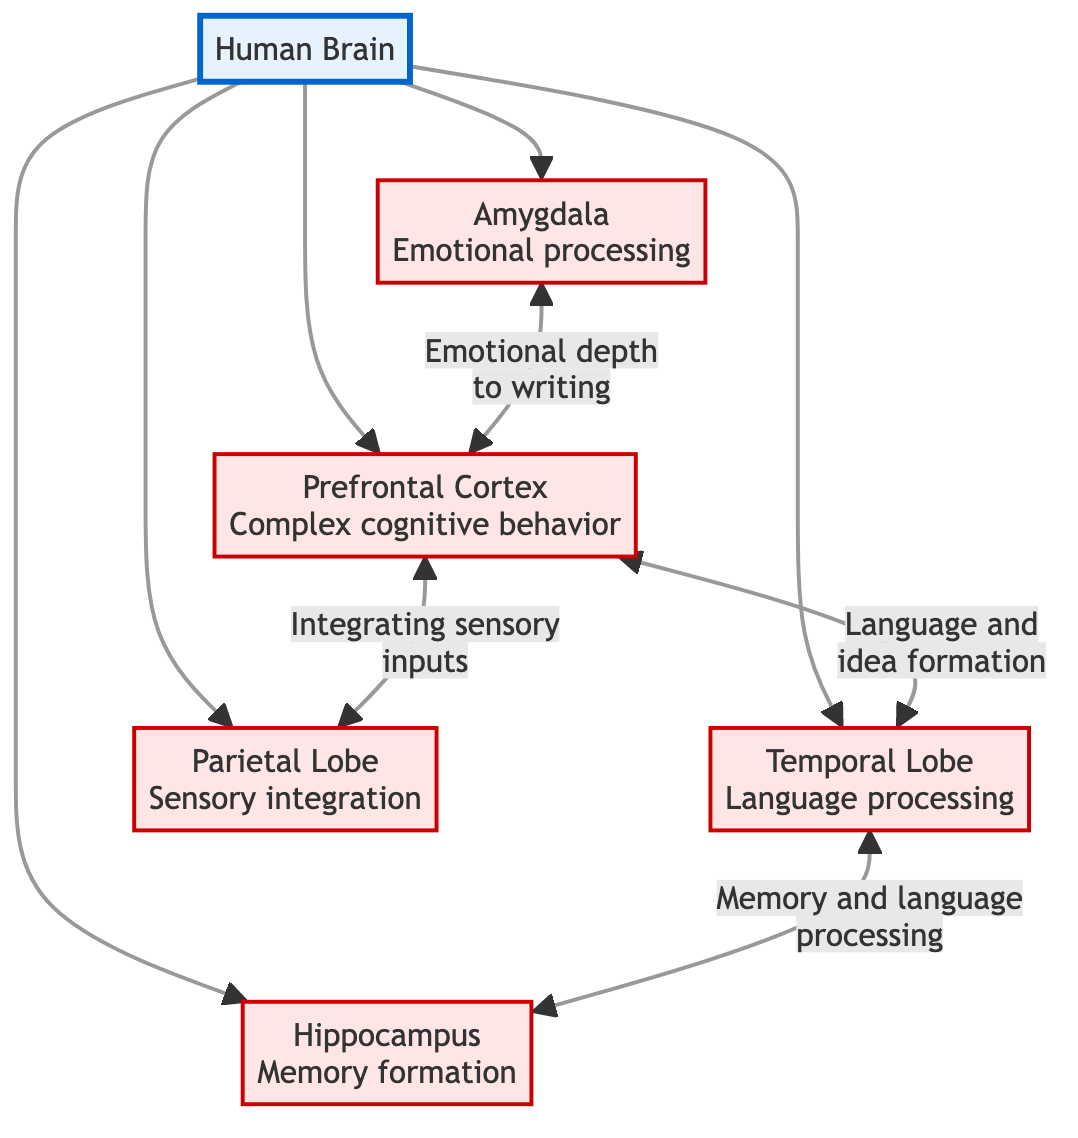What brain region is responsible for complex cognitive behavior? The diagram identifies the Prefrontal Cortex as the region associated with complex cognitive behavior. This can be directly observed as a labeled node connected to the Human Brain node.
Answer: Prefrontal Cortex How many brain regions are involved in the creative writing process according to the diagram? The diagram shows five distinct regions: Prefrontal Cortex, Temporal Lobe, Parietal Lobe, Hippocampus, and Amygdala, all branching from the Human Brain node.
Answer: Five What is the relationship between the Prefrontal Cortex and the Temporal Lobe? The diagram illustrates a bidirectional connection between the Prefrontal Cortex and the Temporal Lobe, indicating they communicate about language and idea formation. This is clearly represented by the connecting edge labeled "Language and idea formation."
Answer: Language and idea formation Which brain region is linked to emotional processing? The diagram designates the Amygdala as the region linked to emotional processing, visually depicted through its labeling in the diagram. This connection focuses on the emotional depth related to writing as indicated in the flowchart.
Answer: Amygdala What does the connection between the Temporal Lobe and Hippocampus pertain to? The diagram indicates that the connection between the Temporal Lobe and the Hippocampus revolves around "Memory and language processing." This is shown through the labeled edge connecting the two regions, emphasizing their interplay in novel-writing.
Answer: Memory and language processing Which brain region integrates sensory inputs? The diagram shows that the Parietal Lobe is responsible for integrating sensory inputs, as it is labeled accordingly next to its node. It is linked to the Prefrontal Cortex, indicating a relationship to complex decision-making processes.
Answer: Parietal Lobe How does the Amygdala interact with the Prefrontal Cortex? According to the diagram, the interaction between the Amygdala and the Prefrontal Cortex is described as influencing the emotional depth to writing. This is represented by a bidirectional link that indicates their communicative relationship.
Answer: Emotional depth to writing What is the primary function associated with the Hippocampus in the creative writing process? The diagram specifies that the Hippocampus is primarily involved in memory formation, which is illustrated through its connection to other brain regions, notably the Temporal Lobe for language processing.
Answer: Memory formation 